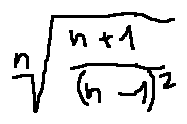Convert formula to latex. <formula><loc_0><loc_0><loc_500><loc_500>\sqrt { [ } n ] { \frac { n + 1 } { ( n - 1 ) ^ { 2 } } }</formula> 